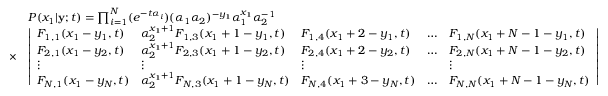<formula> <loc_0><loc_0><loc_500><loc_500>\begin{array} { r l } & { P ( x _ { 1 } | y ; t ) = \prod _ { i = 1 } ^ { N } ( e ^ { - t \alpha _ { i } } ) ( \alpha _ { 1 } \alpha _ { 2 } ) ^ { - y _ { 1 } } \alpha _ { 1 } ^ { x _ { 1 } } \alpha _ { 2 } ^ { - 1 } } \\ { \times } & { \left | \begin{array} { l l l l l } { F _ { 1 , 1 } ( x _ { 1 } - y _ { 1 } , t ) } & { \alpha _ { 2 } ^ { x _ { 1 } + 1 } F _ { 1 , 3 } ( x _ { 1 } + 1 - y _ { 1 } , t ) } & { F _ { 1 , 4 } ( x _ { 1 } + 2 - y _ { 1 } , t ) } & { \dots } & { F _ { 1 , N } ( x _ { 1 } + N - 1 - y _ { 1 } , t ) } \\ { F _ { 2 , 1 } ( x _ { 1 } - y _ { 2 } , t ) } & { \alpha _ { 2 } ^ { x _ { 1 } + 1 } F _ { 2 , 3 } ( x _ { 1 } + 1 - y _ { 2 } , t ) } & { F _ { 2 , 4 } ( x _ { 1 } + 2 - y _ { 2 } , t ) } & { \dots } & { F _ { 2 , N } ( x _ { 1 } + N - 1 - y _ { 2 } , t ) } \\ { \vdots } & { \vdots } & { \vdots } & & { \vdots } \\ { F _ { N , 1 } ( x _ { 1 } - y _ { N } , t ) } & { \alpha _ { 2 } ^ { x _ { 1 } + 1 } F _ { N , 3 } ( x _ { 1 } + 1 - y _ { N } , t ) } & { F _ { N , 4 } ( x _ { 1 } + 3 - y _ { N } , t ) } & { \dots } & { F _ { N , N } ( x _ { 1 } + N - 1 - y _ { N } , t ) } \end{array} \right | } \end{array}</formula> 